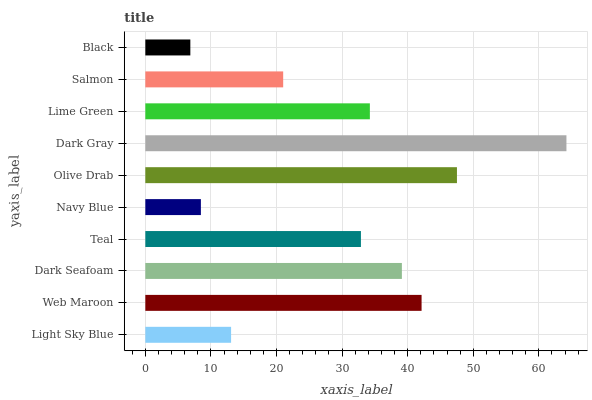Is Black the minimum?
Answer yes or no. Yes. Is Dark Gray the maximum?
Answer yes or no. Yes. Is Web Maroon the minimum?
Answer yes or no. No. Is Web Maroon the maximum?
Answer yes or no. No. Is Web Maroon greater than Light Sky Blue?
Answer yes or no. Yes. Is Light Sky Blue less than Web Maroon?
Answer yes or no. Yes. Is Light Sky Blue greater than Web Maroon?
Answer yes or no. No. Is Web Maroon less than Light Sky Blue?
Answer yes or no. No. Is Lime Green the high median?
Answer yes or no. Yes. Is Teal the low median?
Answer yes or no. Yes. Is Olive Drab the high median?
Answer yes or no. No. Is Salmon the low median?
Answer yes or no. No. 